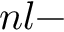<formula> <loc_0><loc_0><loc_500><loc_500>n l -</formula> 